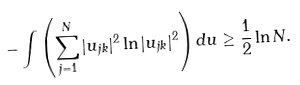<formula> <loc_0><loc_0><loc_500><loc_500>- \int \left ( \sum _ { j = 1 } ^ { N } | u _ { j k } | ^ { 2 } \ln | u _ { j k } | ^ { 2 } \right ) d u \geq \frac { 1 } { 2 } \ln N .</formula> 